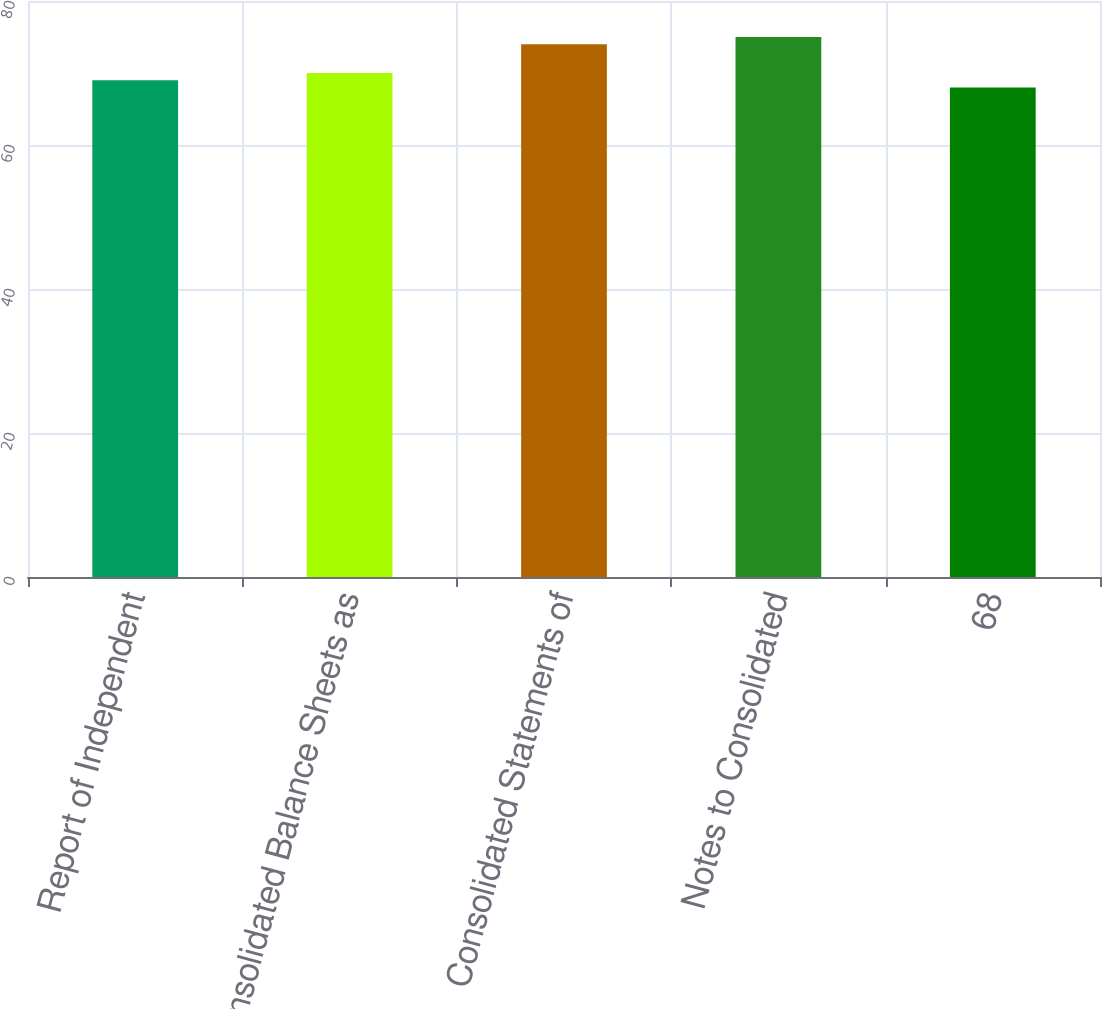Convert chart to OTSL. <chart><loc_0><loc_0><loc_500><loc_500><bar_chart><fcel>Report of Independent<fcel>Consolidated Balance Sheets as<fcel>Consolidated Statements of<fcel>Notes to Consolidated<fcel>68<nl><fcel>69<fcel>70<fcel>74<fcel>75<fcel>68<nl></chart> 